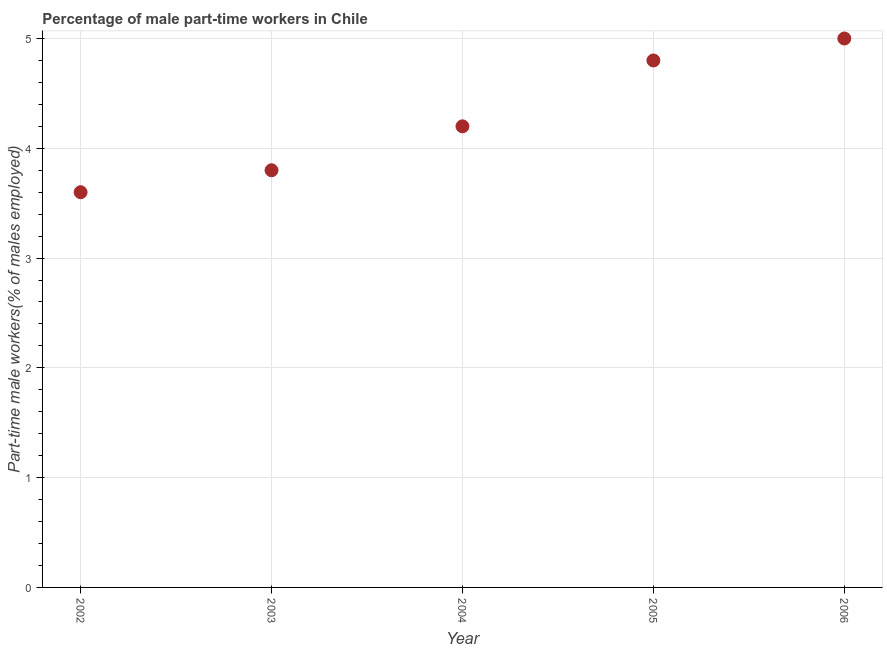What is the percentage of part-time male workers in 2003?
Offer a very short reply. 3.8. Across all years, what is the minimum percentage of part-time male workers?
Your answer should be compact. 3.6. In which year was the percentage of part-time male workers maximum?
Give a very brief answer. 2006. In which year was the percentage of part-time male workers minimum?
Offer a very short reply. 2002. What is the sum of the percentage of part-time male workers?
Offer a very short reply. 21.4. What is the difference between the percentage of part-time male workers in 2002 and 2005?
Provide a short and direct response. -1.2. What is the average percentage of part-time male workers per year?
Offer a terse response. 4.28. What is the median percentage of part-time male workers?
Your response must be concise. 4.2. What is the ratio of the percentage of part-time male workers in 2004 to that in 2006?
Your response must be concise. 0.84. What is the difference between the highest and the second highest percentage of part-time male workers?
Your answer should be compact. 0.2. Is the sum of the percentage of part-time male workers in 2003 and 2004 greater than the maximum percentage of part-time male workers across all years?
Your response must be concise. Yes. What is the difference between the highest and the lowest percentage of part-time male workers?
Offer a very short reply. 1.4. In how many years, is the percentage of part-time male workers greater than the average percentage of part-time male workers taken over all years?
Ensure brevity in your answer.  2. Does the percentage of part-time male workers monotonically increase over the years?
Provide a short and direct response. Yes. What is the difference between two consecutive major ticks on the Y-axis?
Your response must be concise. 1. Are the values on the major ticks of Y-axis written in scientific E-notation?
Your answer should be compact. No. What is the title of the graph?
Your answer should be compact. Percentage of male part-time workers in Chile. What is the label or title of the X-axis?
Make the answer very short. Year. What is the label or title of the Y-axis?
Give a very brief answer. Part-time male workers(% of males employed). What is the Part-time male workers(% of males employed) in 2002?
Your response must be concise. 3.6. What is the Part-time male workers(% of males employed) in 2003?
Give a very brief answer. 3.8. What is the Part-time male workers(% of males employed) in 2004?
Your response must be concise. 4.2. What is the Part-time male workers(% of males employed) in 2005?
Provide a short and direct response. 4.8. What is the Part-time male workers(% of males employed) in 2006?
Provide a succinct answer. 5. What is the difference between the Part-time male workers(% of males employed) in 2002 and 2006?
Offer a very short reply. -1.4. What is the difference between the Part-time male workers(% of males employed) in 2003 and 2004?
Your response must be concise. -0.4. What is the difference between the Part-time male workers(% of males employed) in 2003 and 2005?
Provide a short and direct response. -1. What is the difference between the Part-time male workers(% of males employed) in 2004 and 2006?
Keep it short and to the point. -0.8. What is the ratio of the Part-time male workers(% of males employed) in 2002 to that in 2003?
Keep it short and to the point. 0.95. What is the ratio of the Part-time male workers(% of males employed) in 2002 to that in 2004?
Give a very brief answer. 0.86. What is the ratio of the Part-time male workers(% of males employed) in 2002 to that in 2005?
Provide a short and direct response. 0.75. What is the ratio of the Part-time male workers(% of males employed) in 2002 to that in 2006?
Offer a very short reply. 0.72. What is the ratio of the Part-time male workers(% of males employed) in 2003 to that in 2004?
Provide a succinct answer. 0.91. What is the ratio of the Part-time male workers(% of males employed) in 2003 to that in 2005?
Keep it short and to the point. 0.79. What is the ratio of the Part-time male workers(% of males employed) in 2003 to that in 2006?
Provide a succinct answer. 0.76. What is the ratio of the Part-time male workers(% of males employed) in 2004 to that in 2006?
Ensure brevity in your answer.  0.84. 